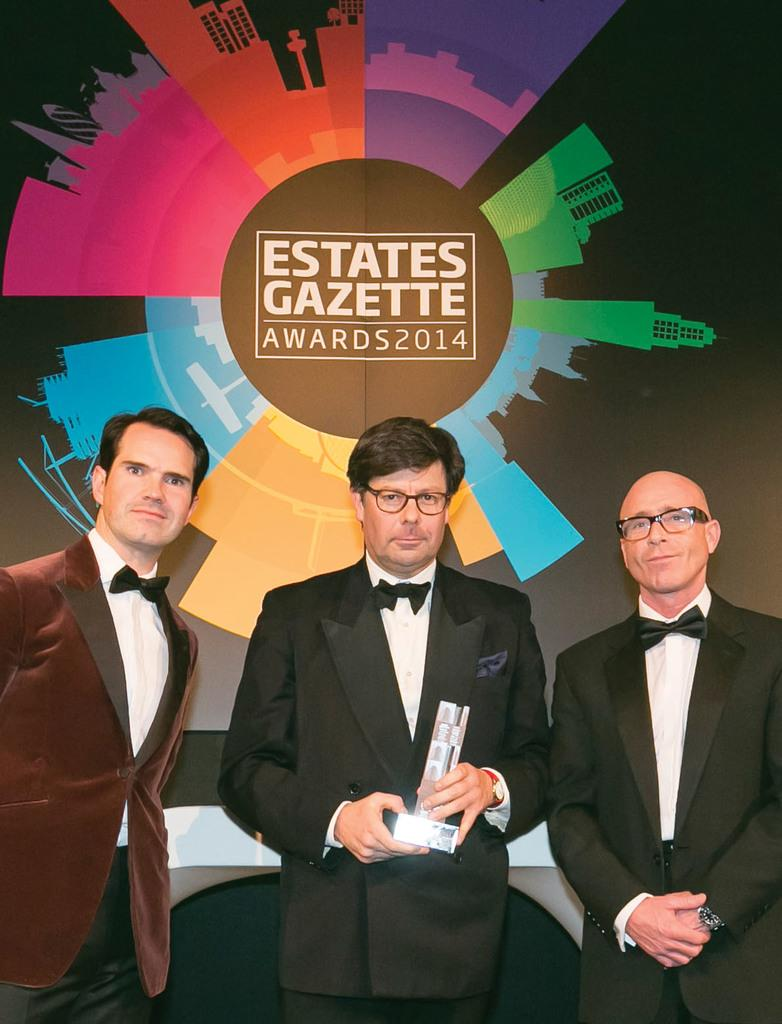What can be seen in the foreground of the image? There are men standing in the foreground of the image. What is located in the background of the image? There is a poster in the background of the image. What type of ear is visible on the poster in the image? There is no ear visible on the poster in the image. What type of quartz can be seen in the hands of the men in the image? There is no quartz present in the image; the men are not holding any quartz. 